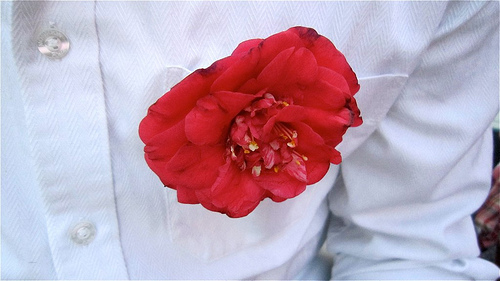<image>
Is the man in front of the flower? No. The man is not in front of the flower. The spatial positioning shows a different relationship between these objects. Where is the flower in relation to the pocket? Is it above the pocket? Yes. The flower is positioned above the pocket in the vertical space, higher up in the scene. 